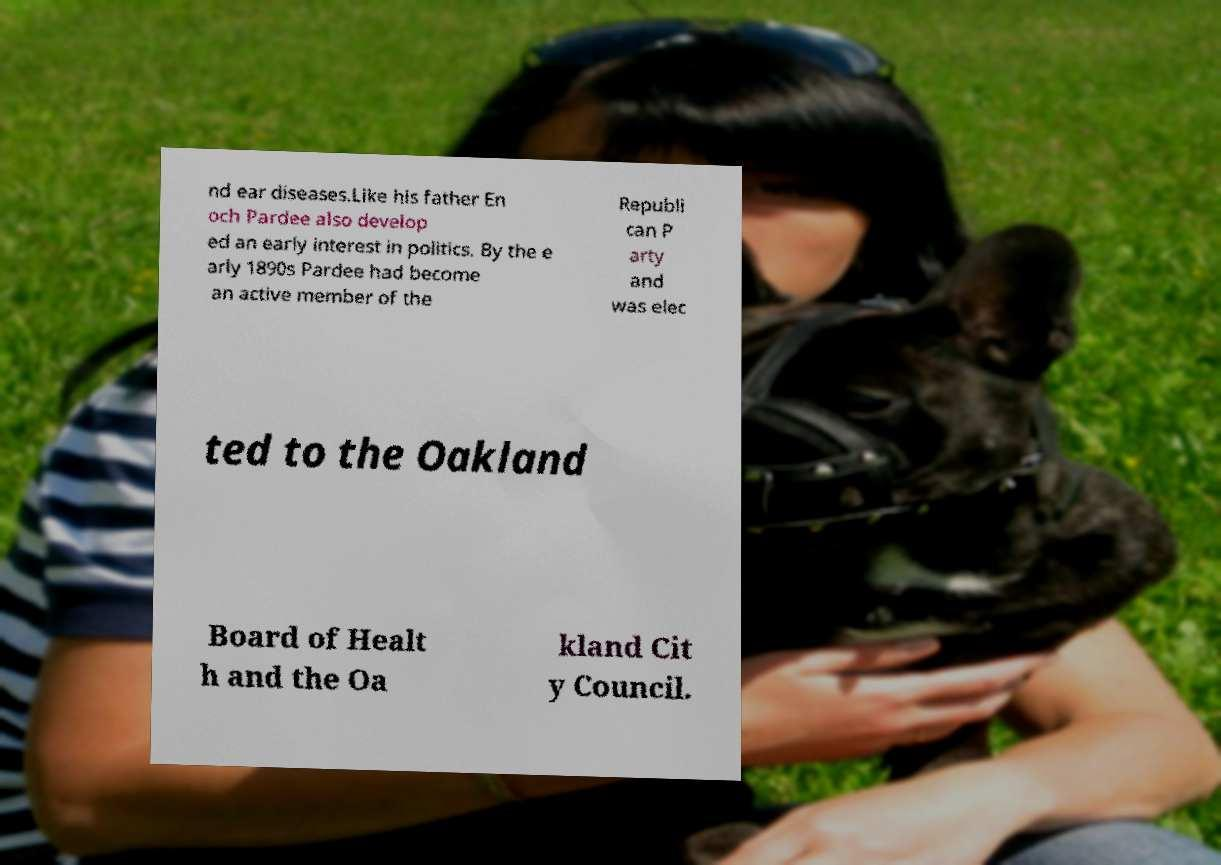I need the written content from this picture converted into text. Can you do that? nd ear diseases.Like his father En och Pardee also develop ed an early interest in politics. By the e arly 1890s Pardee had become an active member of the Republi can P arty and was elec ted to the Oakland Board of Healt h and the Oa kland Cit y Council. 